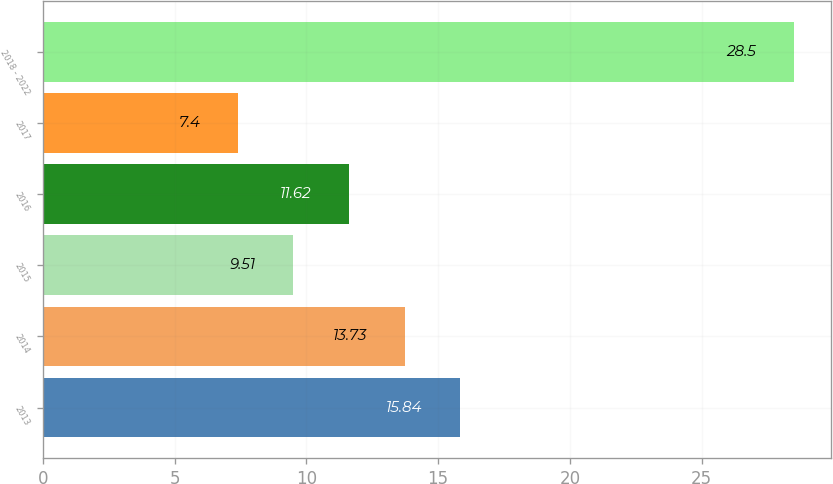Convert chart to OTSL. <chart><loc_0><loc_0><loc_500><loc_500><bar_chart><fcel>2013<fcel>2014<fcel>2015<fcel>2016<fcel>2017<fcel>2018 - 2022<nl><fcel>15.84<fcel>13.73<fcel>9.51<fcel>11.62<fcel>7.4<fcel>28.5<nl></chart> 